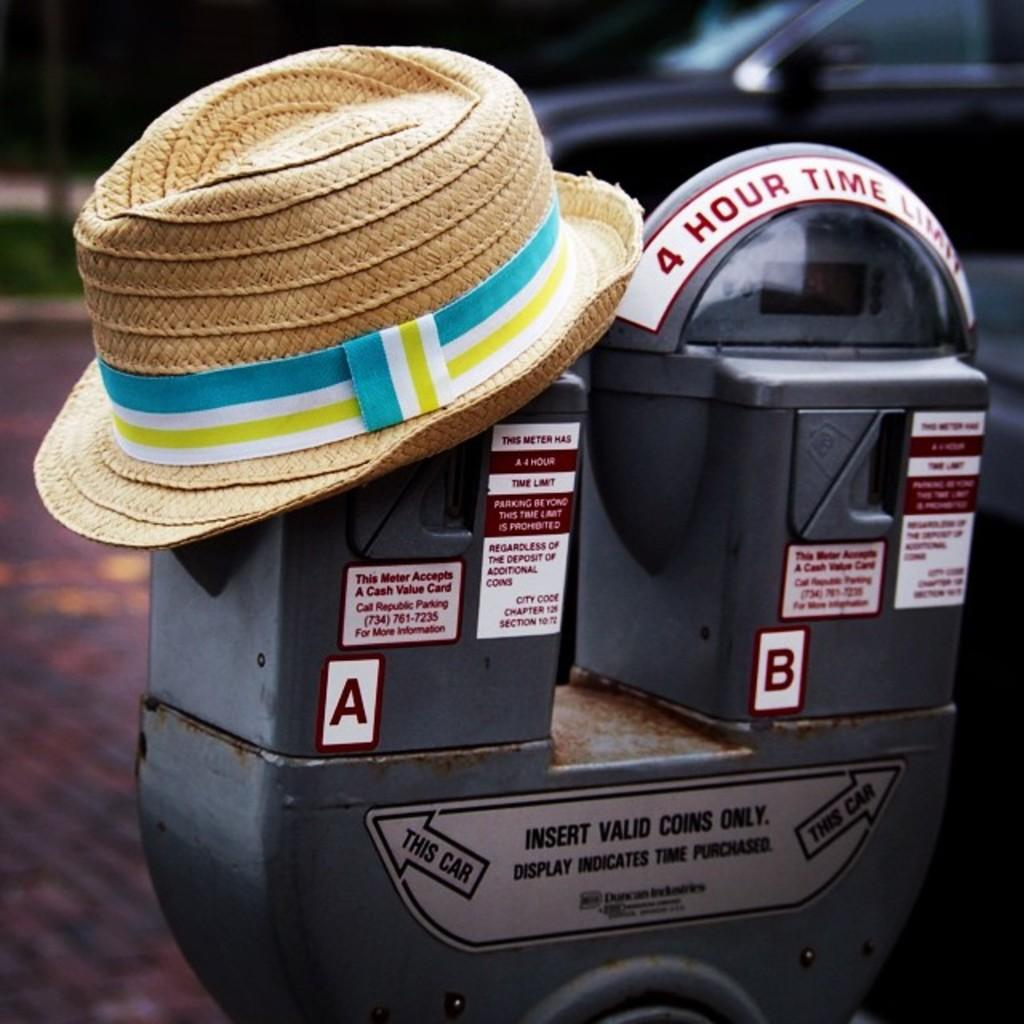<image>
Write a terse but informative summary of the picture. A parking meter with a straw hat on it. It has a 4 hour waiting time limit. 